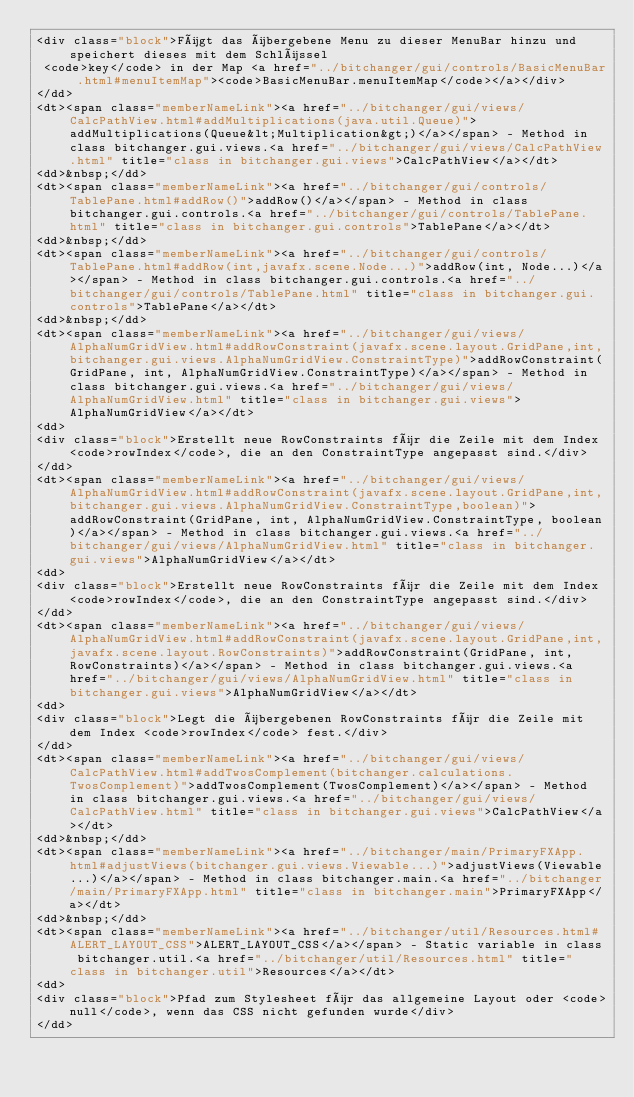<code> <loc_0><loc_0><loc_500><loc_500><_HTML_><div class="block">Fügt das übergebene Menu zu dieser MenuBar hinzu und speichert dieses mit dem Schlüssel
 <code>key</code> in der Map <a href="../bitchanger/gui/controls/BasicMenuBar.html#menuItemMap"><code>BasicMenuBar.menuItemMap</code></a></div>
</dd>
<dt><span class="memberNameLink"><a href="../bitchanger/gui/views/CalcPathView.html#addMultiplications(java.util.Queue)">addMultiplications(Queue&lt;Multiplication&gt;)</a></span> - Method in class bitchanger.gui.views.<a href="../bitchanger/gui/views/CalcPathView.html" title="class in bitchanger.gui.views">CalcPathView</a></dt>
<dd>&nbsp;</dd>
<dt><span class="memberNameLink"><a href="../bitchanger/gui/controls/TablePane.html#addRow()">addRow()</a></span> - Method in class bitchanger.gui.controls.<a href="../bitchanger/gui/controls/TablePane.html" title="class in bitchanger.gui.controls">TablePane</a></dt>
<dd>&nbsp;</dd>
<dt><span class="memberNameLink"><a href="../bitchanger/gui/controls/TablePane.html#addRow(int,javafx.scene.Node...)">addRow(int, Node...)</a></span> - Method in class bitchanger.gui.controls.<a href="../bitchanger/gui/controls/TablePane.html" title="class in bitchanger.gui.controls">TablePane</a></dt>
<dd>&nbsp;</dd>
<dt><span class="memberNameLink"><a href="../bitchanger/gui/views/AlphaNumGridView.html#addRowConstraint(javafx.scene.layout.GridPane,int,bitchanger.gui.views.AlphaNumGridView.ConstraintType)">addRowConstraint(GridPane, int, AlphaNumGridView.ConstraintType)</a></span> - Method in class bitchanger.gui.views.<a href="../bitchanger/gui/views/AlphaNumGridView.html" title="class in bitchanger.gui.views">AlphaNumGridView</a></dt>
<dd>
<div class="block">Erstellt neue RowConstraints für die Zeile mit dem Index <code>rowIndex</code>, die an den ConstraintType angepasst sind.</div>
</dd>
<dt><span class="memberNameLink"><a href="../bitchanger/gui/views/AlphaNumGridView.html#addRowConstraint(javafx.scene.layout.GridPane,int,bitchanger.gui.views.AlphaNumGridView.ConstraintType,boolean)">addRowConstraint(GridPane, int, AlphaNumGridView.ConstraintType, boolean)</a></span> - Method in class bitchanger.gui.views.<a href="../bitchanger/gui/views/AlphaNumGridView.html" title="class in bitchanger.gui.views">AlphaNumGridView</a></dt>
<dd>
<div class="block">Erstellt neue RowConstraints für die Zeile mit dem Index <code>rowIndex</code>, die an den ConstraintType angepasst sind.</div>
</dd>
<dt><span class="memberNameLink"><a href="../bitchanger/gui/views/AlphaNumGridView.html#addRowConstraint(javafx.scene.layout.GridPane,int,javafx.scene.layout.RowConstraints)">addRowConstraint(GridPane, int, RowConstraints)</a></span> - Method in class bitchanger.gui.views.<a href="../bitchanger/gui/views/AlphaNumGridView.html" title="class in bitchanger.gui.views">AlphaNumGridView</a></dt>
<dd>
<div class="block">Legt die übergebenen RowConstraints für die Zeile mit dem Index <code>rowIndex</code> fest.</div>
</dd>
<dt><span class="memberNameLink"><a href="../bitchanger/gui/views/CalcPathView.html#addTwosComplement(bitchanger.calculations.TwosComplement)">addTwosComplement(TwosComplement)</a></span> - Method in class bitchanger.gui.views.<a href="../bitchanger/gui/views/CalcPathView.html" title="class in bitchanger.gui.views">CalcPathView</a></dt>
<dd>&nbsp;</dd>
<dt><span class="memberNameLink"><a href="../bitchanger/main/PrimaryFXApp.html#adjustViews(bitchanger.gui.views.Viewable...)">adjustViews(Viewable...)</a></span> - Method in class bitchanger.main.<a href="../bitchanger/main/PrimaryFXApp.html" title="class in bitchanger.main">PrimaryFXApp</a></dt>
<dd>&nbsp;</dd>
<dt><span class="memberNameLink"><a href="../bitchanger/util/Resources.html#ALERT_LAYOUT_CSS">ALERT_LAYOUT_CSS</a></span> - Static variable in class bitchanger.util.<a href="../bitchanger/util/Resources.html" title="class in bitchanger.util">Resources</a></dt>
<dd>
<div class="block">Pfad zum Stylesheet für das allgemeine Layout oder <code>null</code>, wenn das CSS nicht gefunden wurde</div>
</dd></code> 